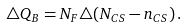Convert formula to latex. <formula><loc_0><loc_0><loc_500><loc_500>\triangle Q _ { B } = N _ { F } \triangle ( N _ { C S } - n _ { C S } ) \, .</formula> 